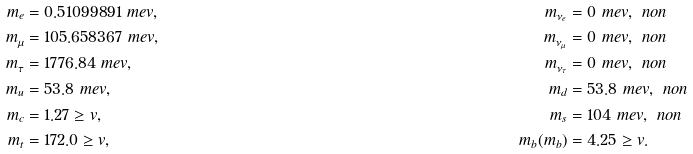<formula> <loc_0><loc_0><loc_500><loc_500>m _ { e } & = 0 . 5 1 0 9 9 8 9 1 \ m e v , & m _ { \nu _ { e } } & = 0 \ m e v , \ n o n \\ m _ { \mu } & = 1 0 5 . 6 5 8 3 6 7 \ m e v , & m _ { \nu _ { \mu } } & = 0 \ m e v , \ n o n \\ m _ { \tau } & = 1 7 7 6 . 8 4 \ m e v , & m _ { \nu _ { \tau } } & = 0 \ m e v , \ n o n \\ m _ { u } & = 5 3 . 8 \ m e v , & m _ { d } & = 5 3 . 8 \ m e v , \ n o n \\ m _ { c } & = 1 . 2 7 \geq v , & m _ { s } & = 1 0 4 \ m e v , \ n o n \\ m _ { t } & = 1 7 2 . 0 \geq v , & m _ { b } ( m _ { b } ) & = 4 . 2 5 \geq v .</formula> 